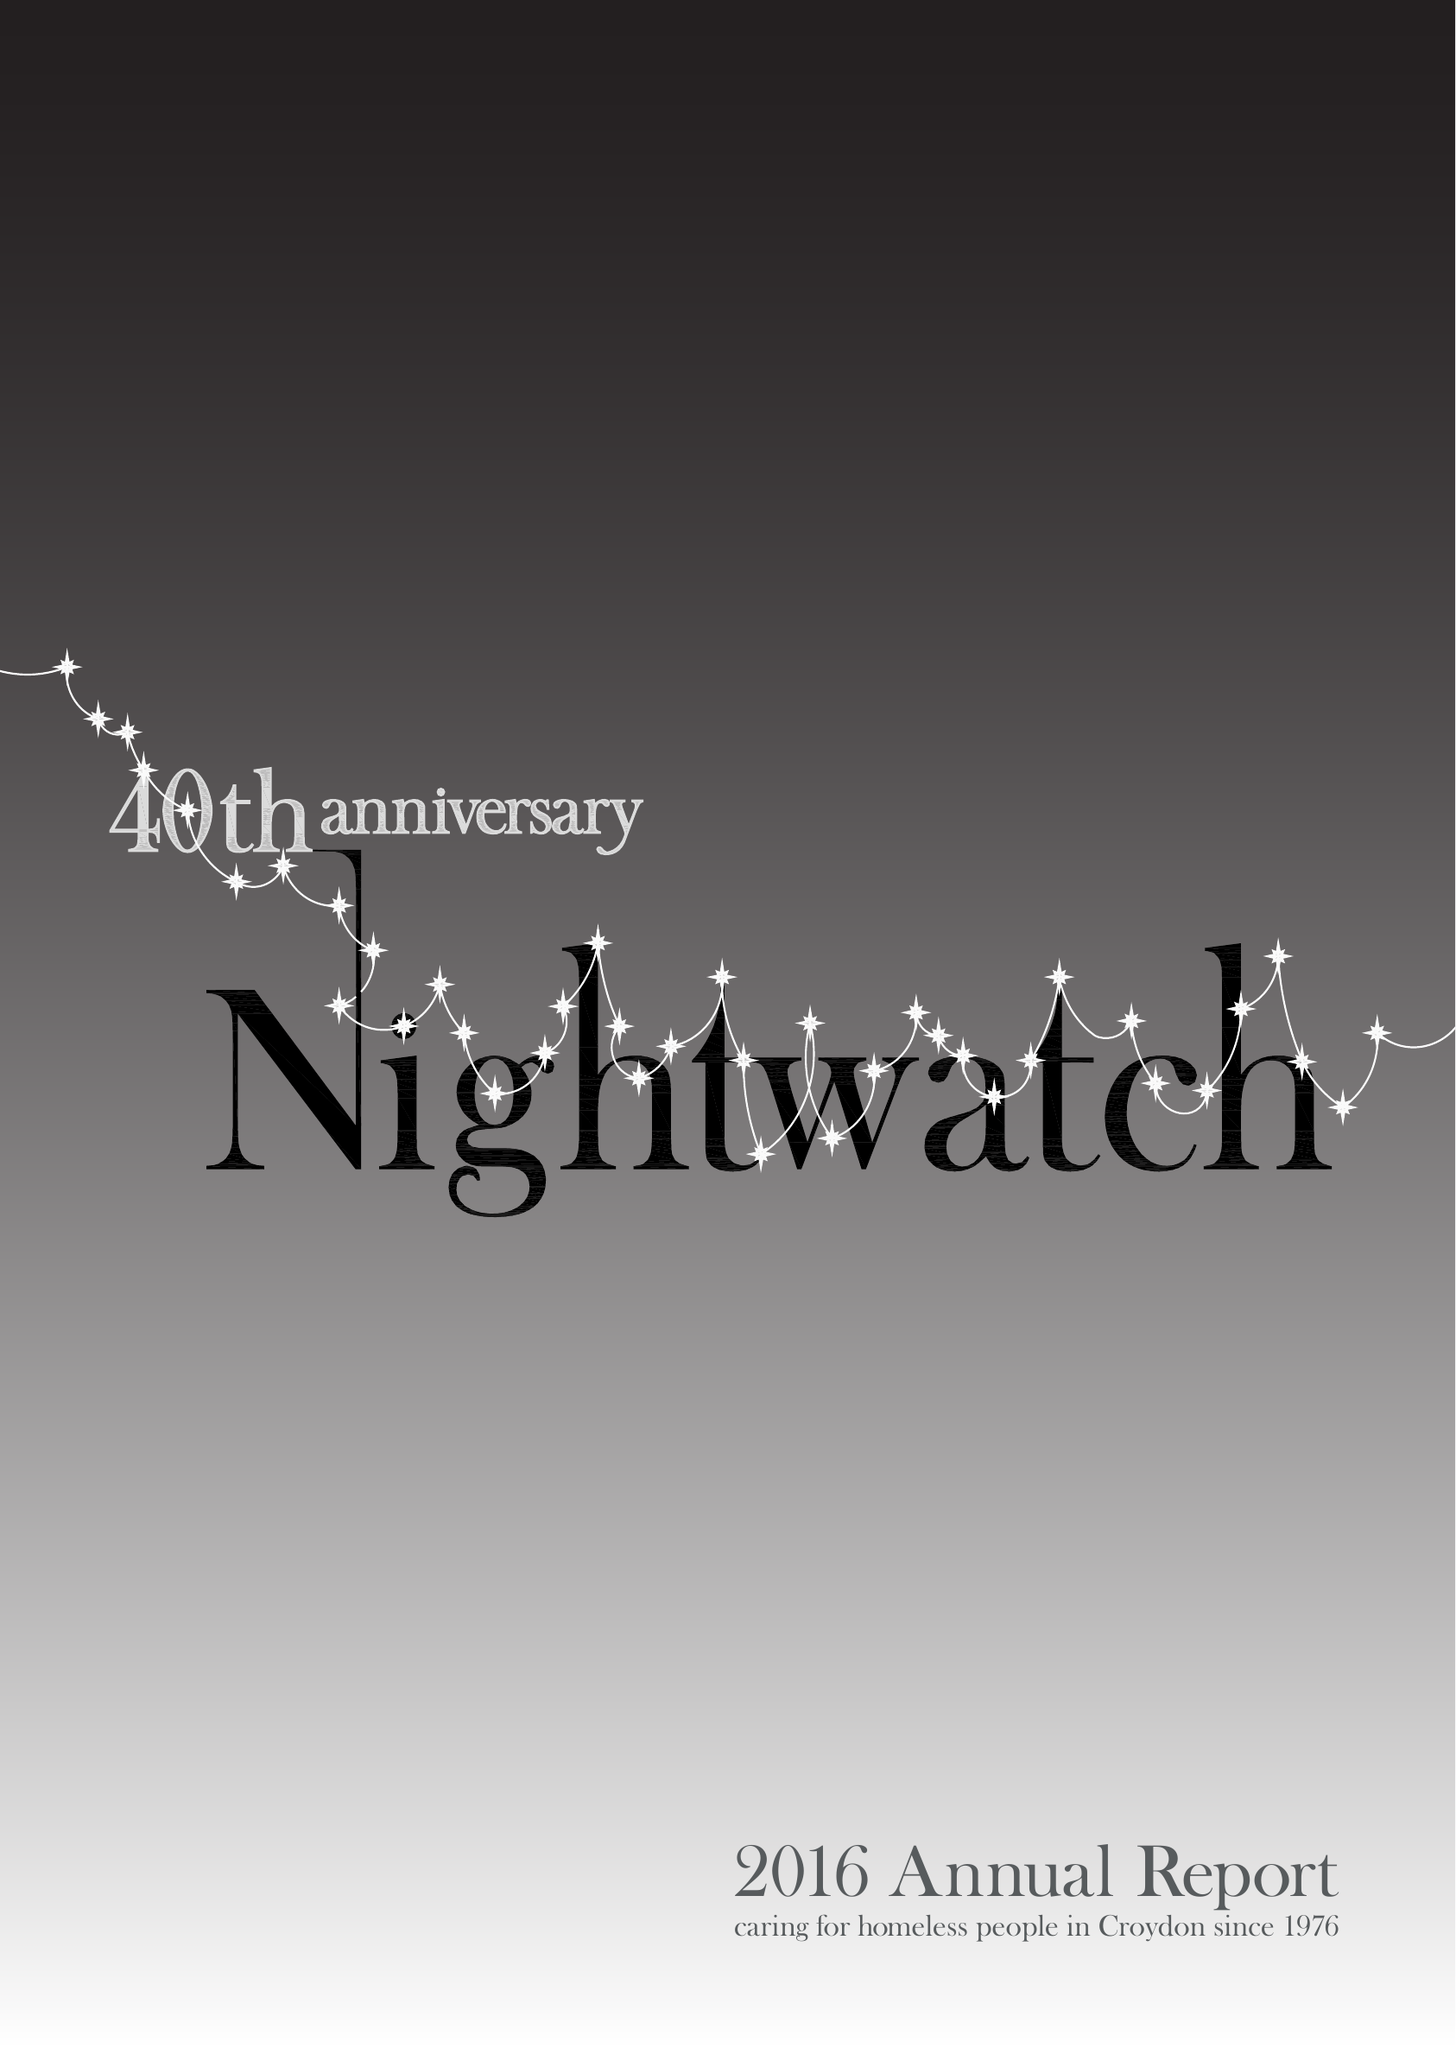What is the value for the charity_number?
Answer the question using a single word or phrase. 274925 